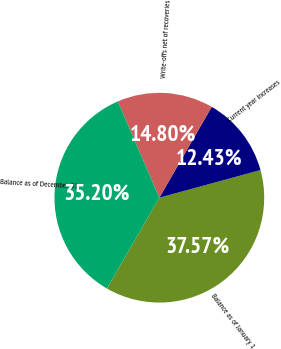Convert chart to OTSL. <chart><loc_0><loc_0><loc_500><loc_500><pie_chart><fcel>Balance as of January 1<fcel>Current year increases<fcel>Write-offs net of recoveries<fcel>Balance as of December 31<nl><fcel>37.57%<fcel>12.43%<fcel>14.8%<fcel>35.2%<nl></chart> 